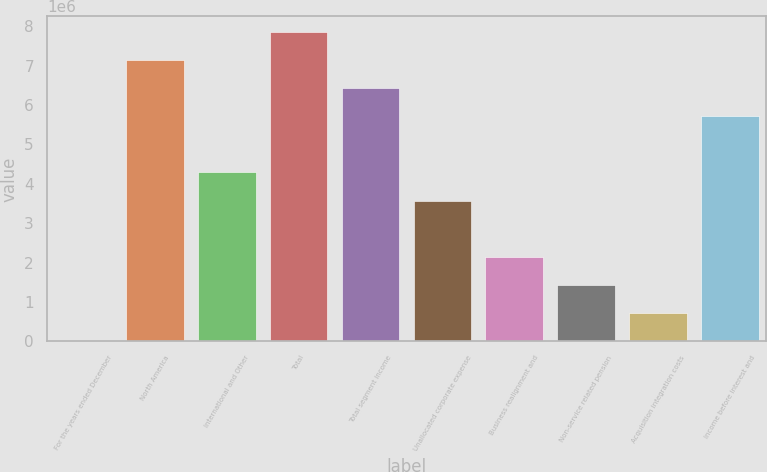<chart> <loc_0><loc_0><loc_500><loc_500><bar_chart><fcel>For the years ended December<fcel>North America<fcel>International and Other<fcel>Total<fcel>Total segment income<fcel>Unallocated corporate expense<fcel>Business realignment and<fcel>Non-service related pension<fcel>Acquisition integration costs<fcel>Income before interest and<nl><fcel>2013<fcel>7.14608e+06<fcel>4.28845e+06<fcel>7.86049e+06<fcel>6.43167e+06<fcel>3.57405e+06<fcel>2.14523e+06<fcel>1.43083e+06<fcel>716420<fcel>5.71727e+06<nl></chart> 